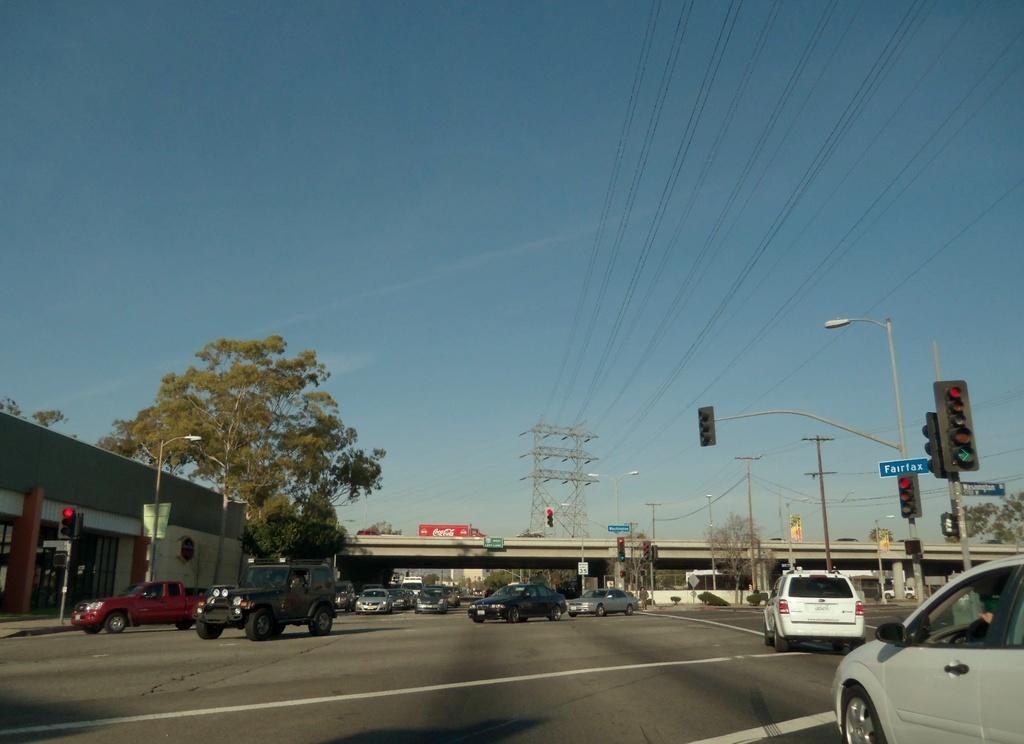Can you describe this image briefly? In this image we can see vehicles on the road, street lights, trees, boards on the poles, traffic signal poles, vehicles on the bridge, wires and clouds in the sky. On the left side we can see a store and objects 